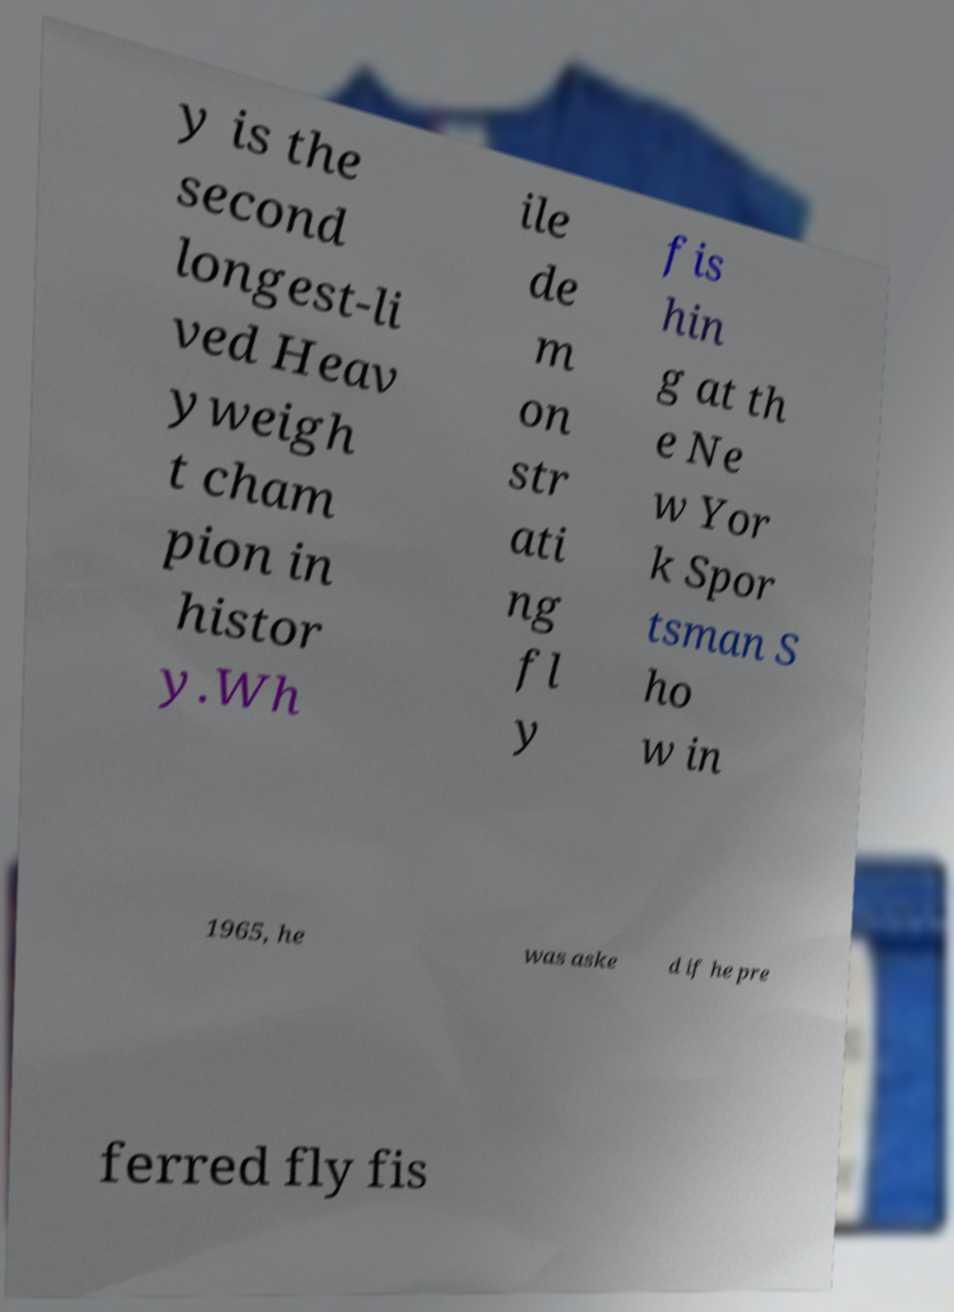Please read and relay the text visible in this image. What does it say? y is the second longest-li ved Heav yweigh t cham pion in histor y.Wh ile de m on str ati ng fl y fis hin g at th e Ne w Yor k Spor tsman S ho w in 1965, he was aske d if he pre ferred fly fis 